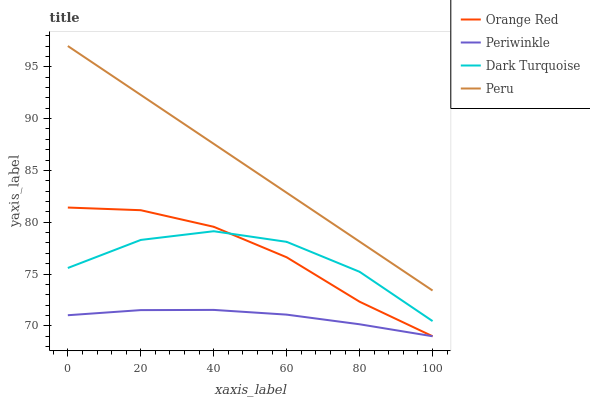Does Orange Red have the minimum area under the curve?
Answer yes or no. No. Does Orange Red have the maximum area under the curve?
Answer yes or no. No. Is Periwinkle the smoothest?
Answer yes or no. No. Is Periwinkle the roughest?
Answer yes or no. No. Does Peru have the lowest value?
Answer yes or no. No. Does Orange Red have the highest value?
Answer yes or no. No. Is Periwinkle less than Peru?
Answer yes or no. Yes. Is Peru greater than Periwinkle?
Answer yes or no. Yes. Does Periwinkle intersect Peru?
Answer yes or no. No. 